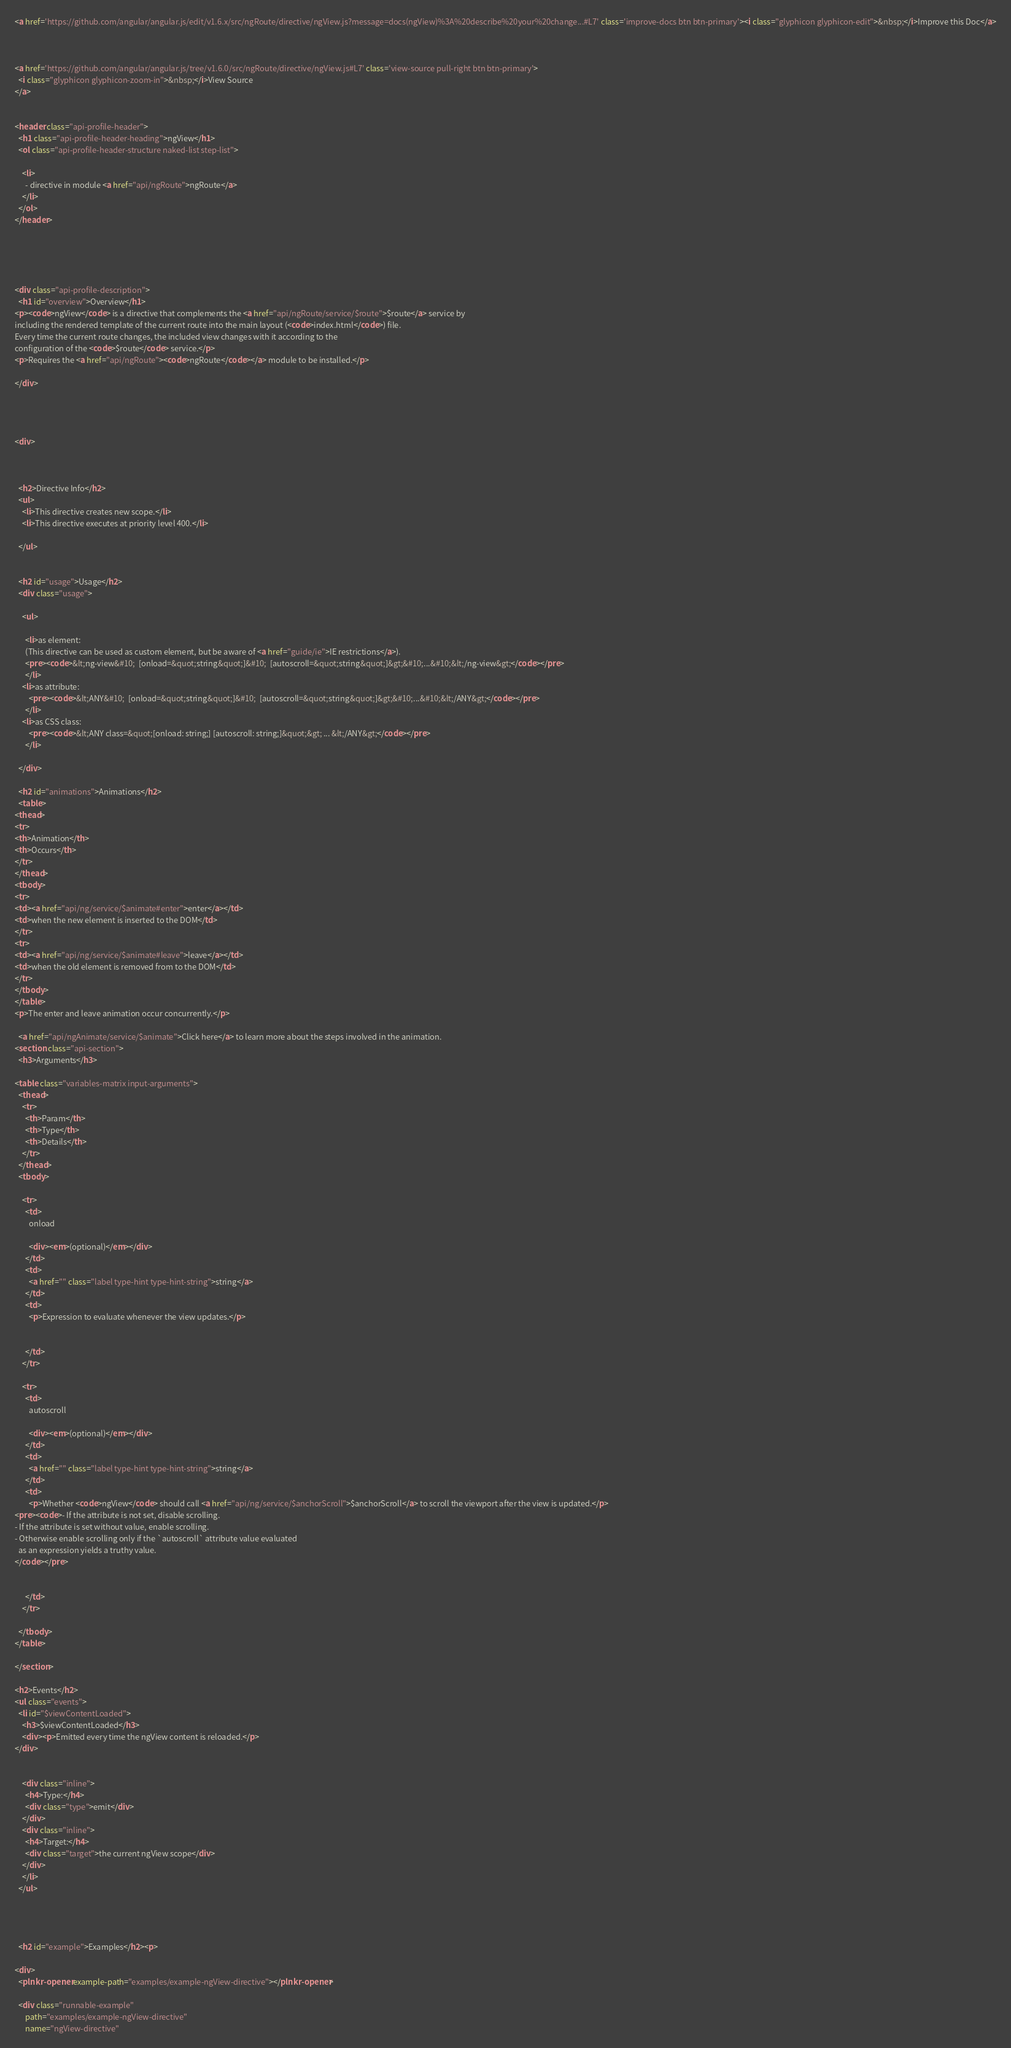<code> <loc_0><loc_0><loc_500><loc_500><_HTML_><a href='https://github.com/angular/angular.js/edit/v1.6.x/src/ngRoute/directive/ngView.js?message=docs(ngView)%3A%20describe%20your%20change...#L7' class='improve-docs btn btn-primary'><i class="glyphicon glyphicon-edit">&nbsp;</i>Improve this Doc</a>



<a href='https://github.com/angular/angular.js/tree/v1.6.0/src/ngRoute/directive/ngView.js#L7' class='view-source pull-right btn btn-primary'>
  <i class="glyphicon glyphicon-zoom-in">&nbsp;</i>View Source
</a>


<header class="api-profile-header">
  <h1 class="api-profile-header-heading">ngView</h1>
  <ol class="api-profile-header-structure naked-list step-list">
    
    <li>
      - directive in module <a href="api/ngRoute">ngRoute</a>
    </li>
  </ol>
</header>





<div class="api-profile-description">
  <h1 id="overview">Overview</h1>
<p><code>ngView</code> is a directive that complements the <a href="api/ngRoute/service/$route">$route</a> service by
including the rendered template of the current route into the main layout (<code>index.html</code>) file.
Every time the current route changes, the included view changes with it according to the
configuration of the <code>$route</code> service.</p>
<p>Requires the <a href="api/ngRoute"><code>ngRoute</code></a> module to be installed.</p>

</div>




<div>
  

  
  <h2>Directive Info</h2>
  <ul>
    <li>This directive creates new scope.</li>
    <li>This directive executes at priority level 400.</li>
    
  </ul>

  
  <h2 id="usage">Usage</h2>
  <div class="usage">
  
    <ul>
    
      <li>as element:
      (This directive can be used as custom element, but be aware of <a href="guide/ie">IE restrictions</a>).
      <pre><code>&lt;ng-view&#10;  [onload=&quot;string&quot;]&#10;  [autoscroll=&quot;string&quot;]&gt;&#10;...&#10;&lt;/ng-view&gt;</code></pre>
      </li>
    <li>as attribute:
        <pre><code>&lt;ANY&#10;  [onload=&quot;string&quot;]&#10;  [autoscroll=&quot;string&quot;]&gt;&#10;...&#10;&lt;/ANY&gt;</code></pre>
      </li>
    <li>as CSS class:
        <pre><code>&lt;ANY class=&quot;[onload: string;] [autoscroll: string;]&quot;&gt; ... &lt;/ANY&gt;</code></pre>
      </li>
    
  </div>
  
  <h2 id="animations">Animations</h2>
  <table>
<thead>
<tr>
<th>Animation</th>
<th>Occurs</th>
</tr>
</thead>
<tbody>
<tr>
<td><a href="api/ng/service/$animate#enter">enter</a></td>
<td>when the new element is inserted to the DOM</td>
</tr>
<tr>
<td><a href="api/ng/service/$animate#leave">leave</a></td>
<td>when the old element is removed from to the DOM</td>
</tr>
</tbody>
</table>
<p>The enter and leave animation occur concurrently.</p>

  <a href="api/ngAnimate/service/$animate">Click here</a> to learn more about the steps involved in the animation.
<section class="api-section">
  <h3>Arguments</h3>

<table class="variables-matrix input-arguments">
  <thead>
    <tr>
      <th>Param</th>
      <th>Type</th>
      <th>Details</th>
    </tr>
  </thead>
  <tbody>
    
    <tr>
      <td>
        onload
        
        <div><em>(optional)</em></div>
      </td>
      <td>
        <a href="" class="label type-hint type-hint-string">string</a>
      </td>
      <td>
        <p>Expression to evaluate whenever the view updates.</p>

        
      </td>
    </tr>
    
    <tr>
      <td>
        autoscroll
        
        <div><em>(optional)</em></div>
      </td>
      <td>
        <a href="" class="label type-hint type-hint-string">string</a>
      </td>
      <td>
        <p>Whether <code>ngView</code> should call <a href="api/ng/service/$anchorScroll">$anchorScroll</a> to scroll the viewport after the view is updated.</p>
<pre><code>- If the attribute is not set, disable scrolling.
- If the attribute is set without value, enable scrolling.
- Otherwise enable scrolling only if the `autoscroll` attribute value evaluated
  as an expression yields a truthy value.
</code></pre>

        
      </td>
    </tr>
    
  </tbody>
</table>

</section>
  
<h2>Events</h2>
<ul class="events">
  <li id="$viewContentLoaded">
    <h3>$viewContentLoaded</h3>
    <div><p>Emitted every time the ngView content is reloaded.</p>
</div>

    
    <div class="inline">
      <h4>Type:</h4>
      <div class="type">emit</div>
    </div>
    <div class="inline">
      <h4>Target:</h4>
      <div class="target">the current ngView scope</div>
    </div>
    </li>
  </ul>



  
  <h2 id="example">Examples</h2><p>

<div>
  <plnkr-opener example-path="examples/example-ngView-directive"></plnkr-opener>

  <div class="runnable-example"
      path="examples/example-ngView-directive"
      name="ngView-directive"</code> 